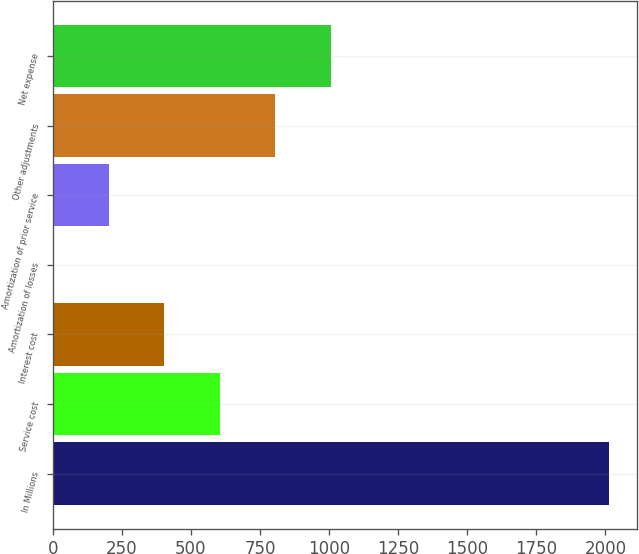Convert chart to OTSL. <chart><loc_0><loc_0><loc_500><loc_500><bar_chart><fcel>In Millions<fcel>Service cost<fcel>Interest cost<fcel>Amortization of losses<fcel>Amortization of prior service<fcel>Other adjustments<fcel>Net expense<nl><fcel>2015<fcel>604.99<fcel>403.56<fcel>0.7<fcel>202.13<fcel>806.42<fcel>1007.85<nl></chart> 